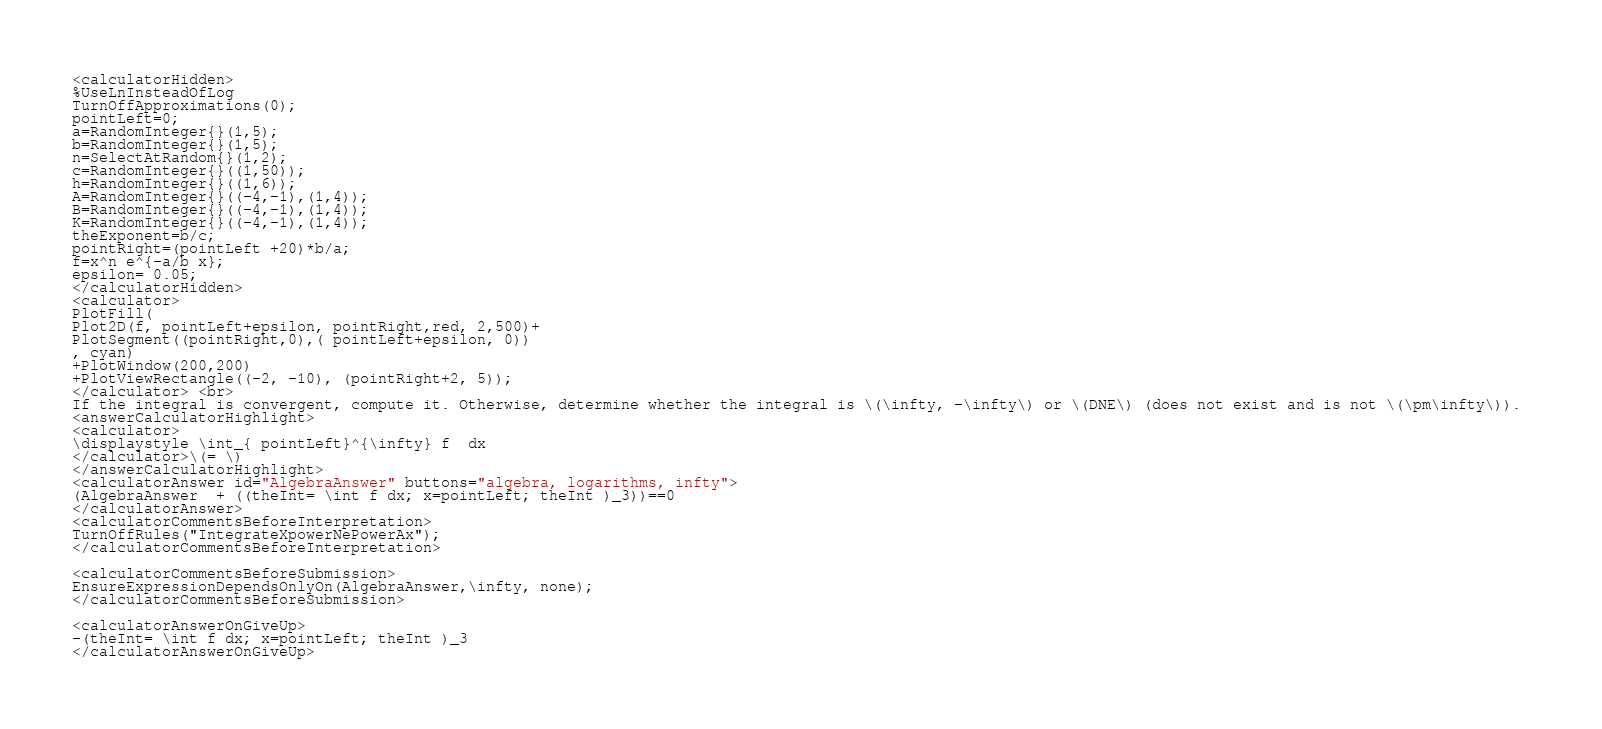<code> <loc_0><loc_0><loc_500><loc_500><_HTML_><calculatorHidden>
%UseLnInsteadOfLog
TurnOffApproximations(0);
pointLeft=0;
a=RandomInteger{}(1,5);
b=RandomInteger{}(1,5);
n=SelectAtRandom{}(1,2);
c=RandomInteger{}((1,50));
h=RandomInteger{}((1,6));
A=RandomInteger{}((-4,-1),(1,4));
B=RandomInteger{}((-4,-1),(1,4));
K=RandomInteger{}((-4,-1),(1,4));
theExponent=b/c;
pointRight=(pointLeft +20)*b/a;
f=x^n e^{-a/b x};
epsilon= 0.05;
</calculatorHidden>
<calculator>
PlotFill(
Plot2D(f, pointLeft+epsilon, pointRight,red, 2,500)+
PlotSegment((pointRight,0),( pointLeft+epsilon, 0)) 
, cyan)
+PlotWindow(200,200)
+PlotViewRectangle((-2, -10), (pointRight+2, 5));
</calculator> <br>
If the integral is convergent, compute it. Otherwise, determine whether the integral is \(\infty, -\infty\) or \(DNE\) (does not exist and is not \(\pm\infty\)). 
<answerCalculatorHighlight>
<calculator>
\displaystyle \int_{ pointLeft}^{\infty} f  dx
</calculator>\(= \)
</answerCalculatorHighlight>
<calculatorAnswer id="AlgebraAnswer" buttons="algebra, logarithms, infty">
(AlgebraAnswer  + ((theInt= \int f dx; x=pointLeft; theInt )_3))==0
</calculatorAnswer>
<calculatorCommentsBeforeInterpretation>
TurnOffRules("IntegrateXpowerNePowerAx");
</calculatorCommentsBeforeInterpretation>

<calculatorCommentsBeforeSubmission>
EnsureExpressionDependsOnlyOn(AlgebraAnswer,\infty, none);
</calculatorCommentsBeforeSubmission>

<calculatorAnswerOnGiveUp>
-(theInt= \int f dx; x=pointLeft; theInt )_3
</calculatorAnswerOnGiveUp>
</code> 